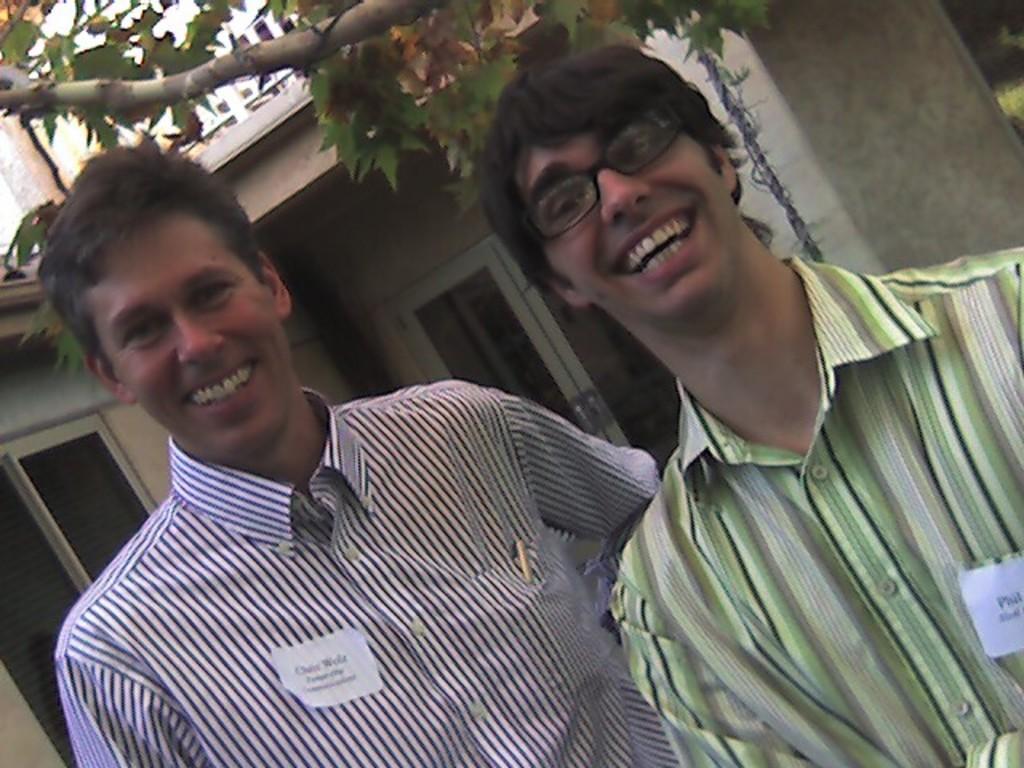Could you give a brief overview of what you see in this image? In this image we can see two people standing near the pillar, name cards attached to the two persons shirts, one tree, one pole and back side one building with windows. 